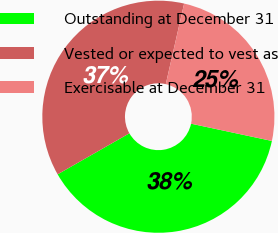Convert chart to OTSL. <chart><loc_0><loc_0><loc_500><loc_500><pie_chart><fcel>Outstanding at December 31<fcel>Vested or expected to vest as<fcel>Exercisable at December 31<nl><fcel>38.39%<fcel>36.83%<fcel>24.79%<nl></chart> 